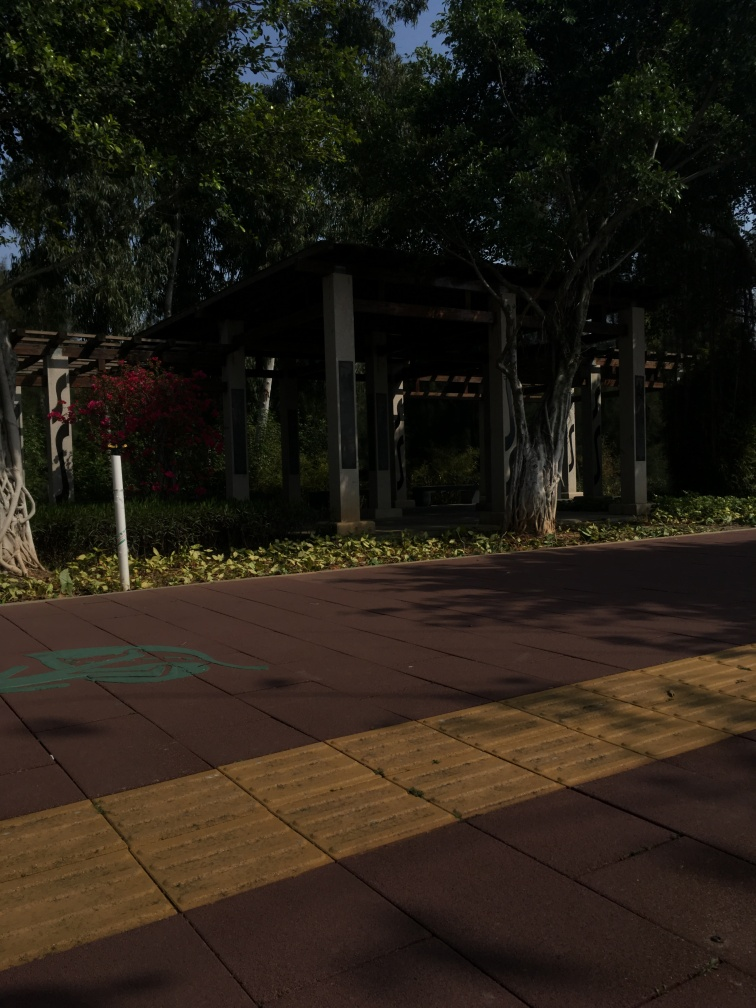What is the purpose of the structures shown in the image? The structures in the image appear to be small open pavilions, which are commonly seen in parks. These are likely designed to offer visitors a shaded retreat where they can rest and enjoy the park's beauty. The open sides allow for natural ventilation and viewing the surrounding landscape while being protected from direct sunlight. They can also serve as a gathering spot for social activities or simply a quiet place to sit and read. 